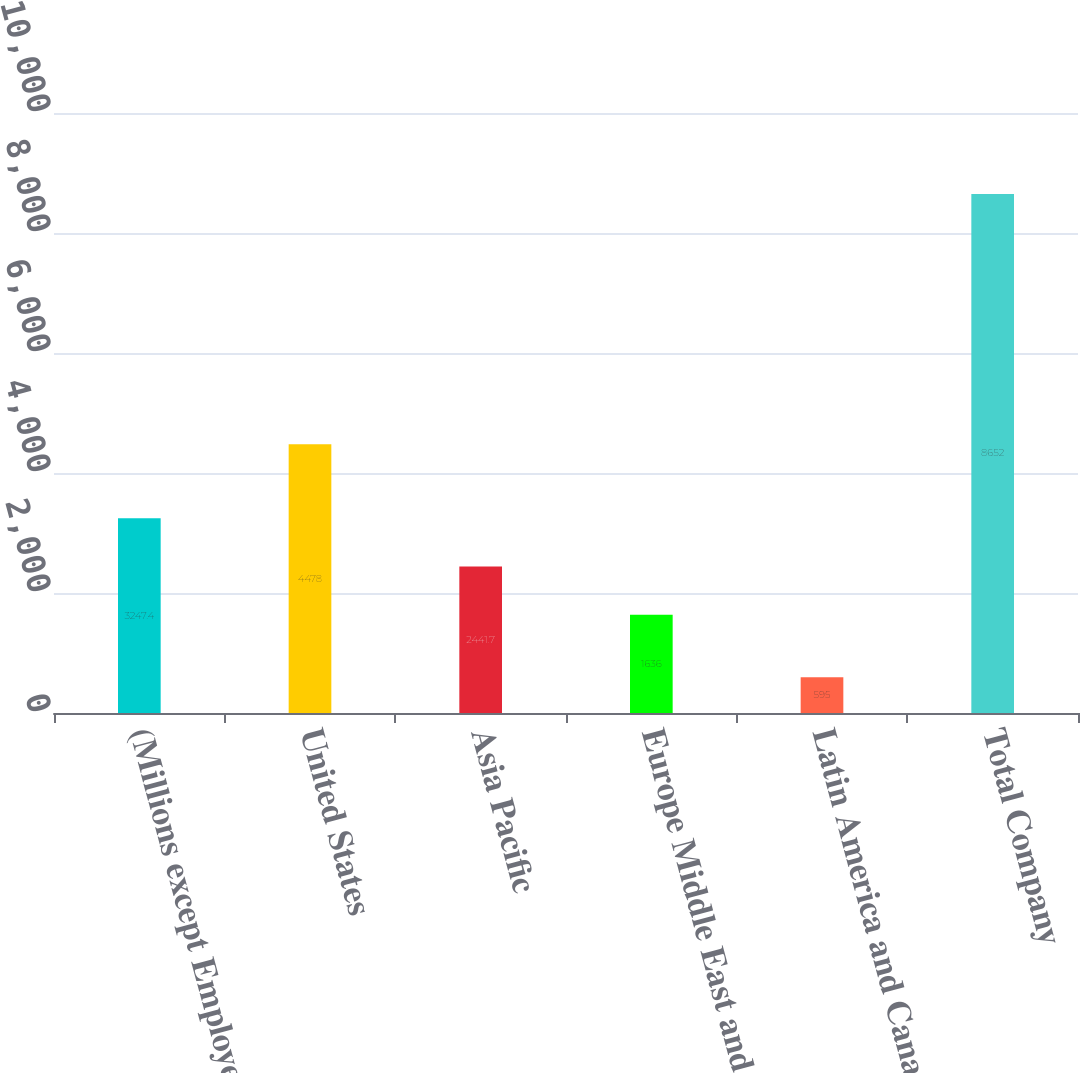<chart> <loc_0><loc_0><loc_500><loc_500><bar_chart><fcel>(Millions except Employees)<fcel>United States<fcel>Asia Pacific<fcel>Europe Middle East and Africa<fcel>Latin America and Canada<fcel>Total Company<nl><fcel>3247.4<fcel>4478<fcel>2441.7<fcel>1636<fcel>595<fcel>8652<nl></chart> 